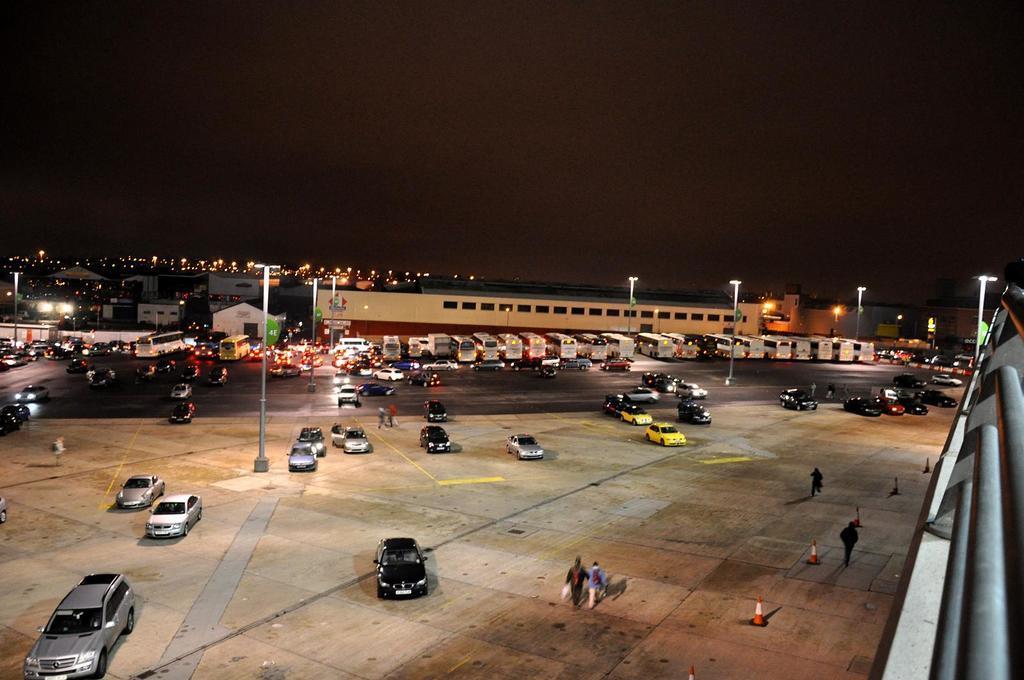Please provide a concise description of this image. In the picture vehicles and people walking on the road. In the background I can see buildings, street light, poles, the sky and some other objects. Here I can see traffic cones. 